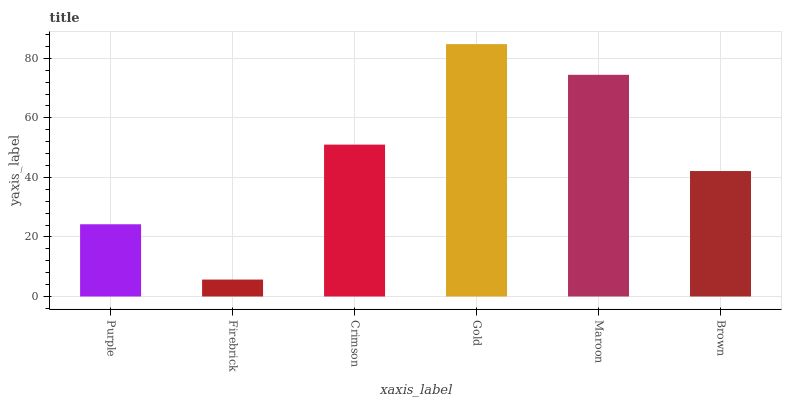Is Crimson the minimum?
Answer yes or no. No. Is Crimson the maximum?
Answer yes or no. No. Is Crimson greater than Firebrick?
Answer yes or no. Yes. Is Firebrick less than Crimson?
Answer yes or no. Yes. Is Firebrick greater than Crimson?
Answer yes or no. No. Is Crimson less than Firebrick?
Answer yes or no. No. Is Crimson the high median?
Answer yes or no. Yes. Is Brown the low median?
Answer yes or no. Yes. Is Maroon the high median?
Answer yes or no. No. Is Gold the low median?
Answer yes or no. No. 